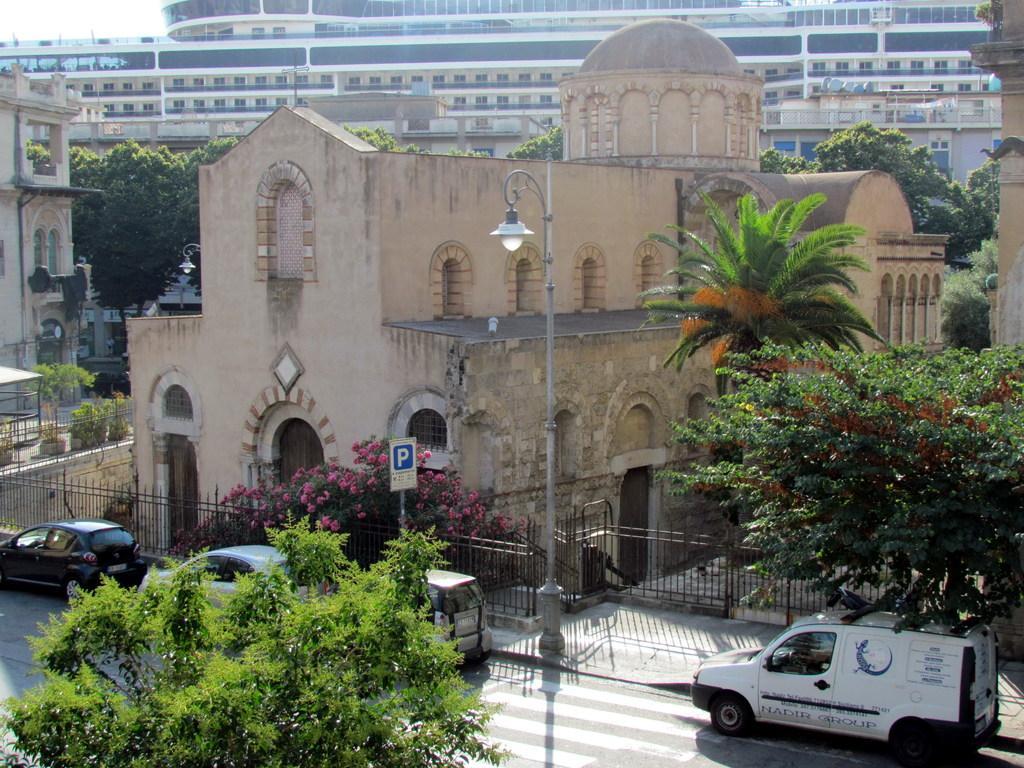How would you summarize this image in a sentence or two? The picture is clicked outside a city on the streets. In the foreground of the picture there are cars, trees and street light. In the center of the picture there are buildings, trees and plants. At the top is a building. Sky is sunny. 